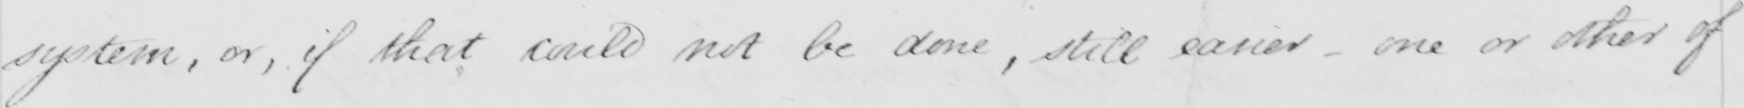Can you read and transcribe this handwriting? system, or, if that could not be done, still easier _ one or other of 